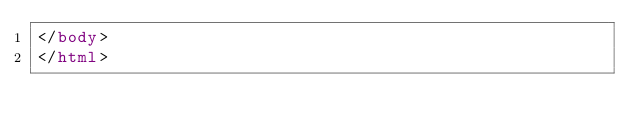Convert code to text. <code><loc_0><loc_0><loc_500><loc_500><_HTML_></body>
</html></code> 